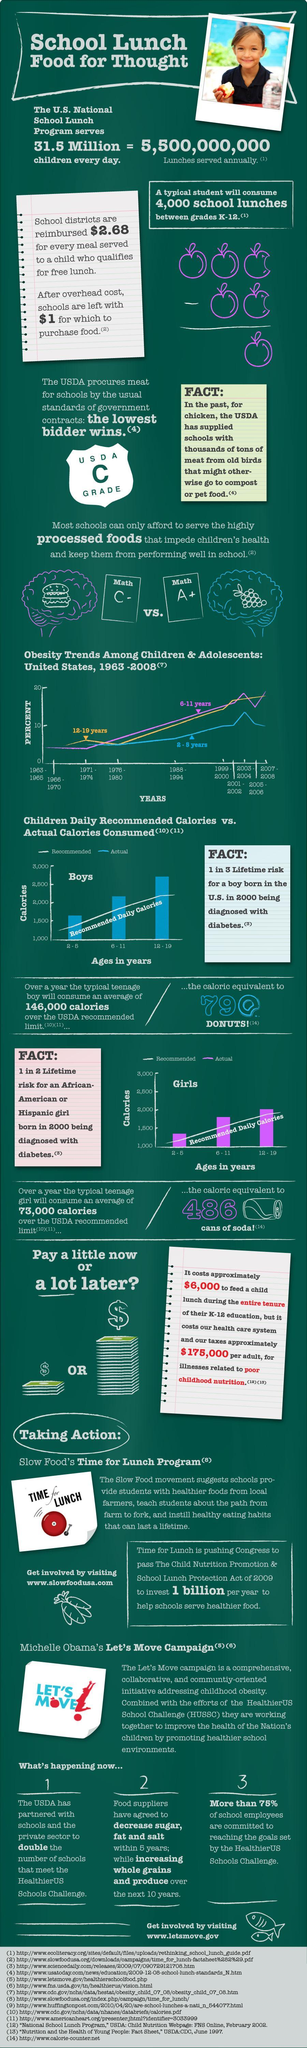In which age group of girls in U.S., the actual calories consumed is between 1000 - 1500 calories?
Answer the question with a short phrase. 2-5 In which age group of boys in U.S., the actual calories consumed is between 2000 - 2500 calories? 6-11 